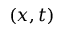Convert formula to latex. <formula><loc_0><loc_0><loc_500><loc_500>( x , t )</formula> 